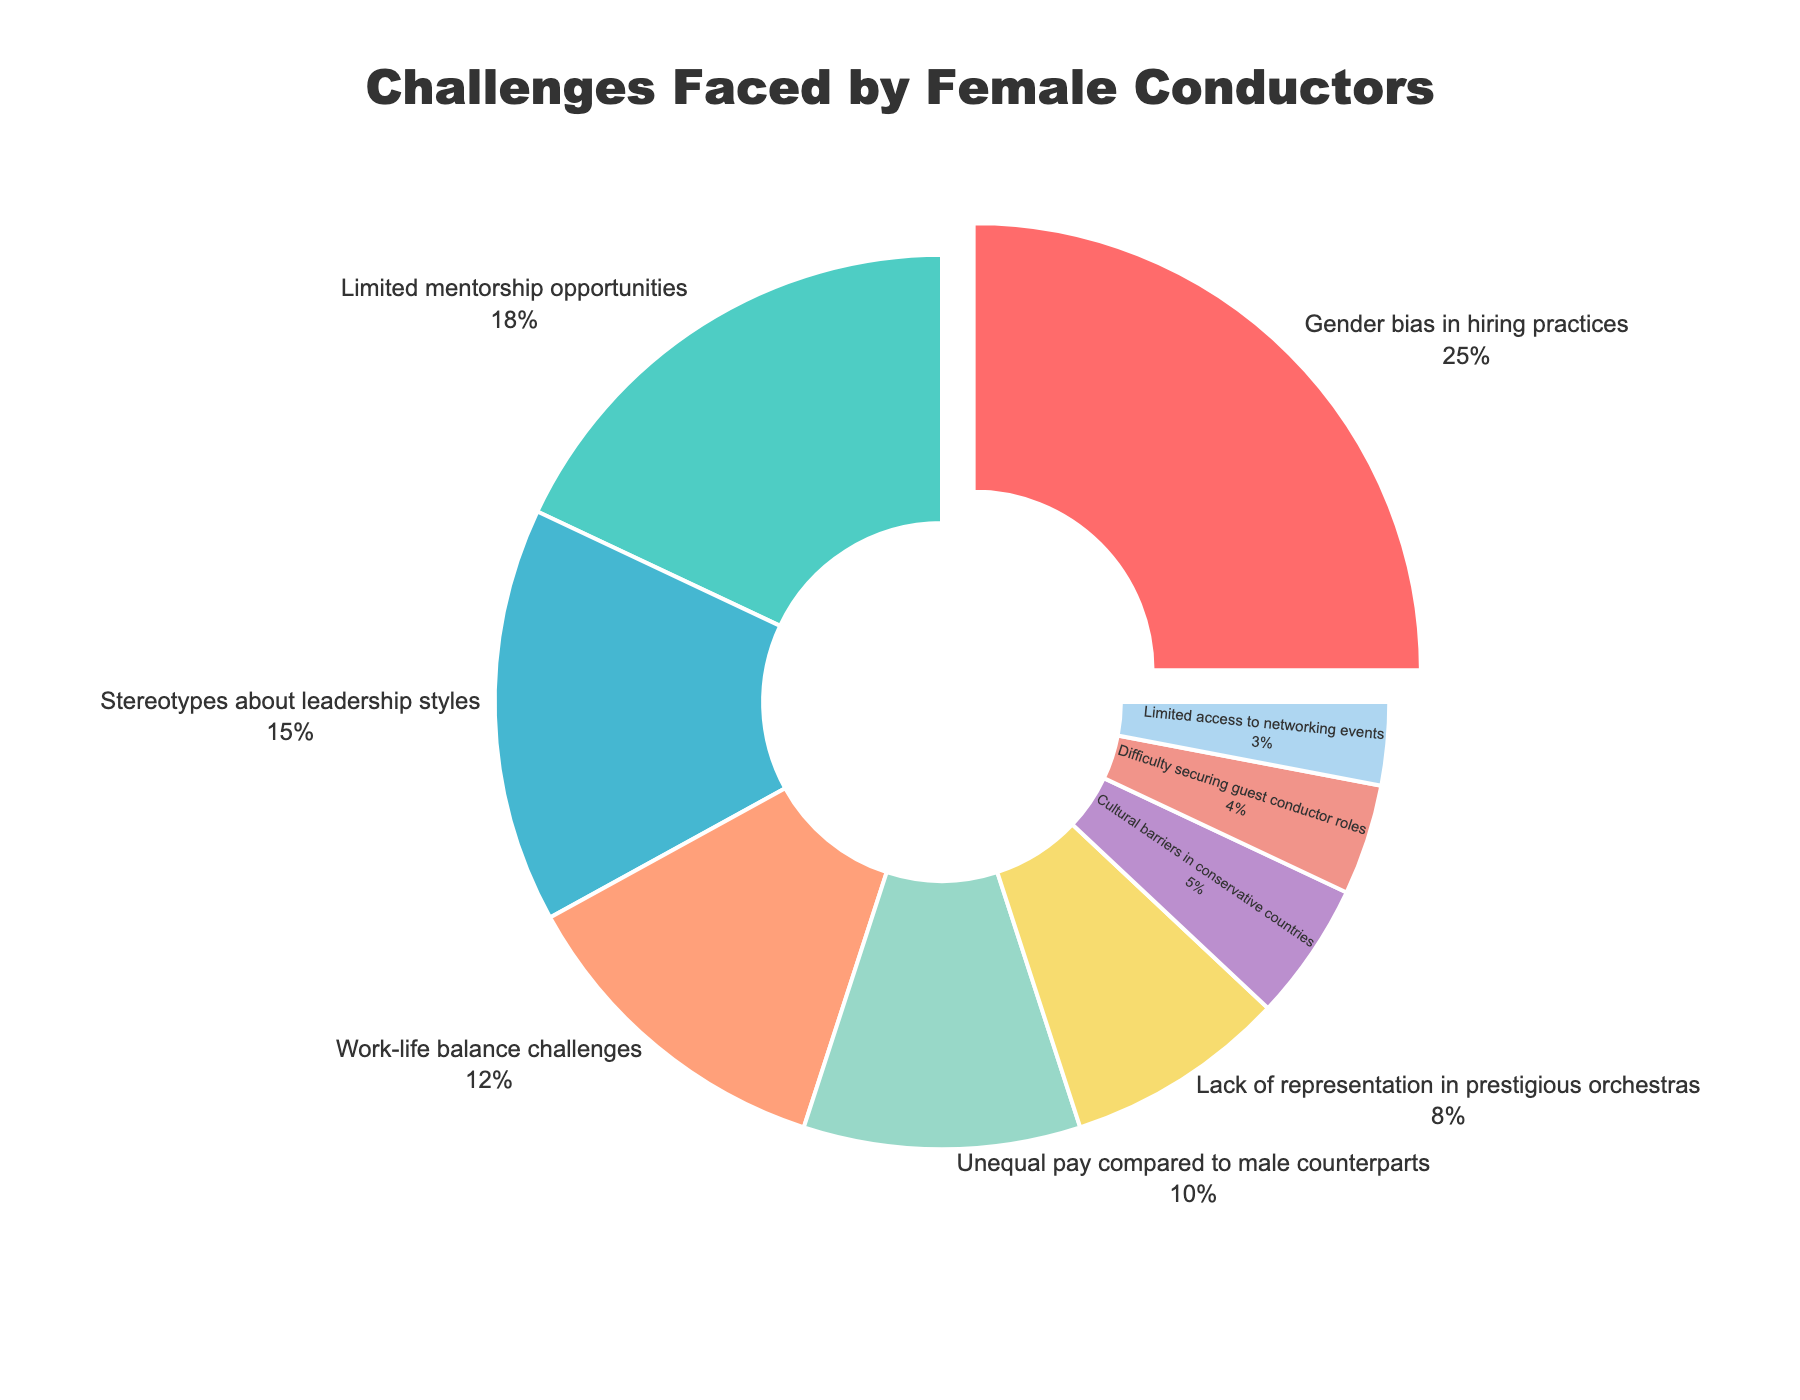What is the largest challenge faced by female conductors according to the chart? The largest section of the pie chart is highlighted and labeled "Gender bias in hiring practices" with 25%, indicating it is the most significant challenge.
Answer: Gender bias in hiring practices How much larger is the percentage for "Limited mentorship opportunities" compared to "Stereotypes about leadership styles"? Limited mentorship opportunities is 18%, and Stereotypes about leadership styles is 15%. The difference is 18% - 15% = 3%.
Answer: 3% Which challenge has the smallest representation on the chart? The smallest segment on the pie chart represents "Limited access to networking events" with 3%.
Answer: Limited access to networking events What is the combined percentage of "Work-life balance challenges" and "Unequal pay compared to male counterparts"? Work-life balance challenges is 12% and Unequal pay compared to male counterparts is 10%. Their combined percentage is 12% + 10% = 22%.
Answer: 22% How does the percentage for "Cultural barriers in conservative countries" compare to "Lack of representation in prestigious orchestras"? Cultural barriers in conservative countries are represented with 5%, while Lack of representation in prestigious orchestras has 8%. Thus, Cultural barriers in conservative countries are 3% less.
Answer: 3% less What color represents the challenge "Gender bias in hiring practices"? The segment for "Gender bias in hiring practices" is colored red. This can be visually identified.
Answer: Red Are the percentages of "Difficulty securing guest conductor roles" and "Limited access to networking events" together more or less than "Unequal pay compared to male counterparts"? Difficulty securing guest conductor roles is 4%, and Limited access to networking events is 3%. Combined, they total 7%. Unequal pay compared to male counterparts is 10%, so the combined percentage is less.
Answer: Less Which challenge is represented by a yellow segment in the chart? The yellow segment of the pie chart represents "Lack of representation in prestigious orchestras".
Answer: Lack of representation in prestigious orchestras How much higher is the percentage facing "Work-life balance challenges" than "Cultural barriers in conservative countries"? Work-life balance challenges is 12%, while Cultural barriers in conservative countries is 5%. The difference is 12% - 5% = 7%.
Answer: 7% What percentage of the chart is made up of "Stereotypes about leadership styles" and "Limited mentorship opportunities"? Stereotypes about leadership styles is 15% and Limited mentorship opportunities is 18%. Their combined percentage is 15% + 18% = 33%.
Answer: 33% 